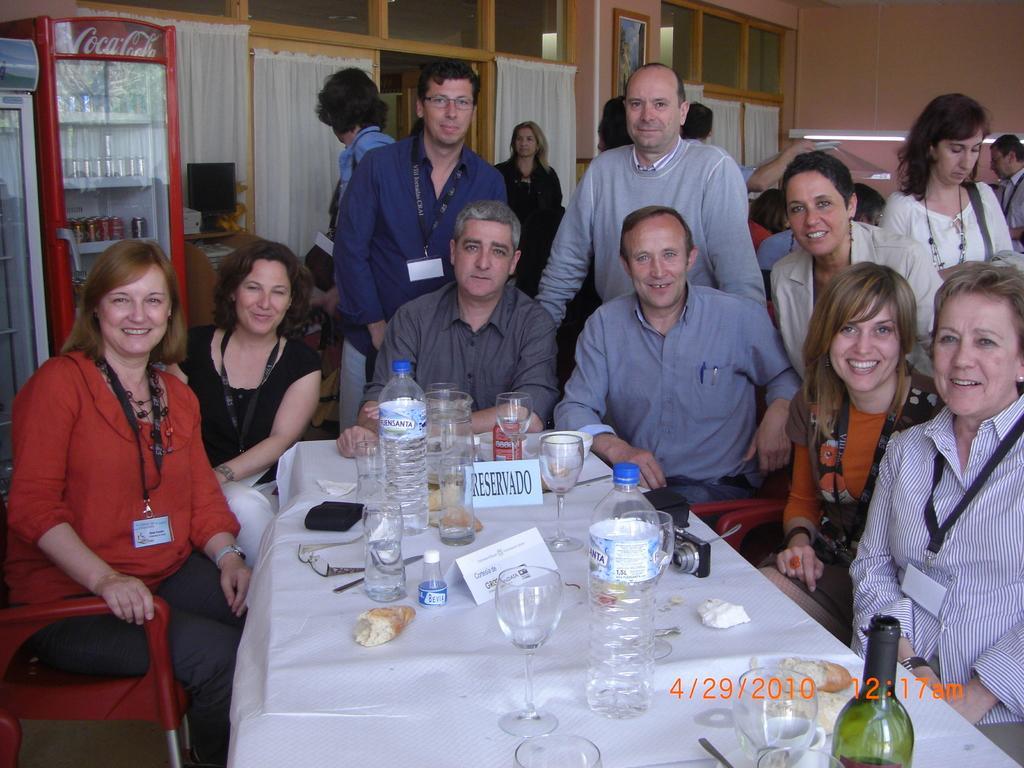In one or two sentences, can you explain what this image depicts? In this room there are many people. In front few are sitting,in the back few are standing. We can also see wall,doors,curtain,frame and fridge. Here in the middle there is a table on which water bottles,glasses,wine bottle,food item,camera are there. 